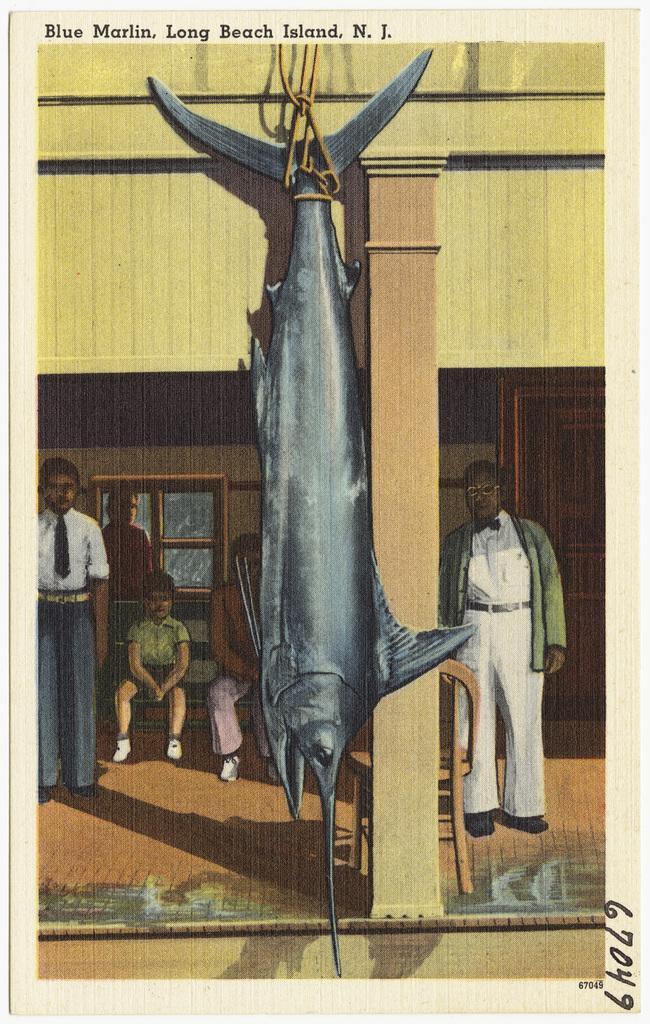Could you give a brief overview of what you see in this image? In this image we can see a big black color fish which is hanged and in the background of the image there are some group of persons standing and some are sitting on the bench, there is a wall, door and window. 